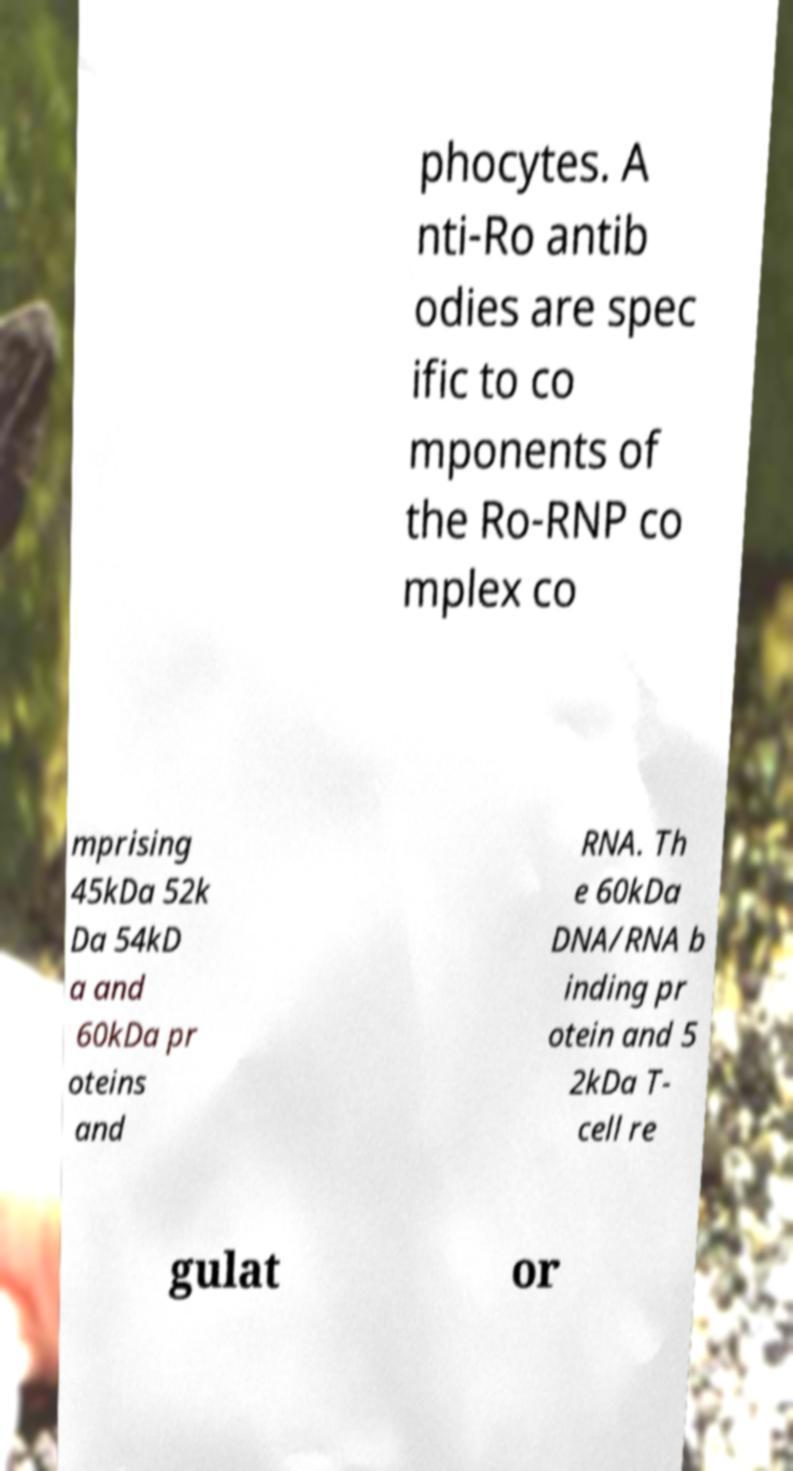I need the written content from this picture converted into text. Can you do that? phocytes. A nti-Ro antib odies are spec ific to co mponents of the Ro-RNP co mplex co mprising 45kDa 52k Da 54kD a and 60kDa pr oteins and RNA. Th e 60kDa DNA/RNA b inding pr otein and 5 2kDa T- cell re gulat or 